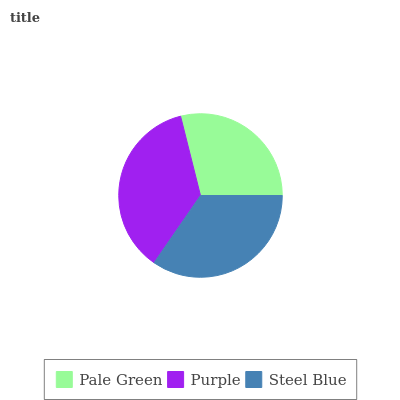Is Pale Green the minimum?
Answer yes or no. Yes. Is Purple the maximum?
Answer yes or no. Yes. Is Steel Blue the minimum?
Answer yes or no. No. Is Steel Blue the maximum?
Answer yes or no. No. Is Purple greater than Steel Blue?
Answer yes or no. Yes. Is Steel Blue less than Purple?
Answer yes or no. Yes. Is Steel Blue greater than Purple?
Answer yes or no. No. Is Purple less than Steel Blue?
Answer yes or no. No. Is Steel Blue the high median?
Answer yes or no. Yes. Is Steel Blue the low median?
Answer yes or no. Yes. Is Pale Green the high median?
Answer yes or no. No. Is Purple the low median?
Answer yes or no. No. 